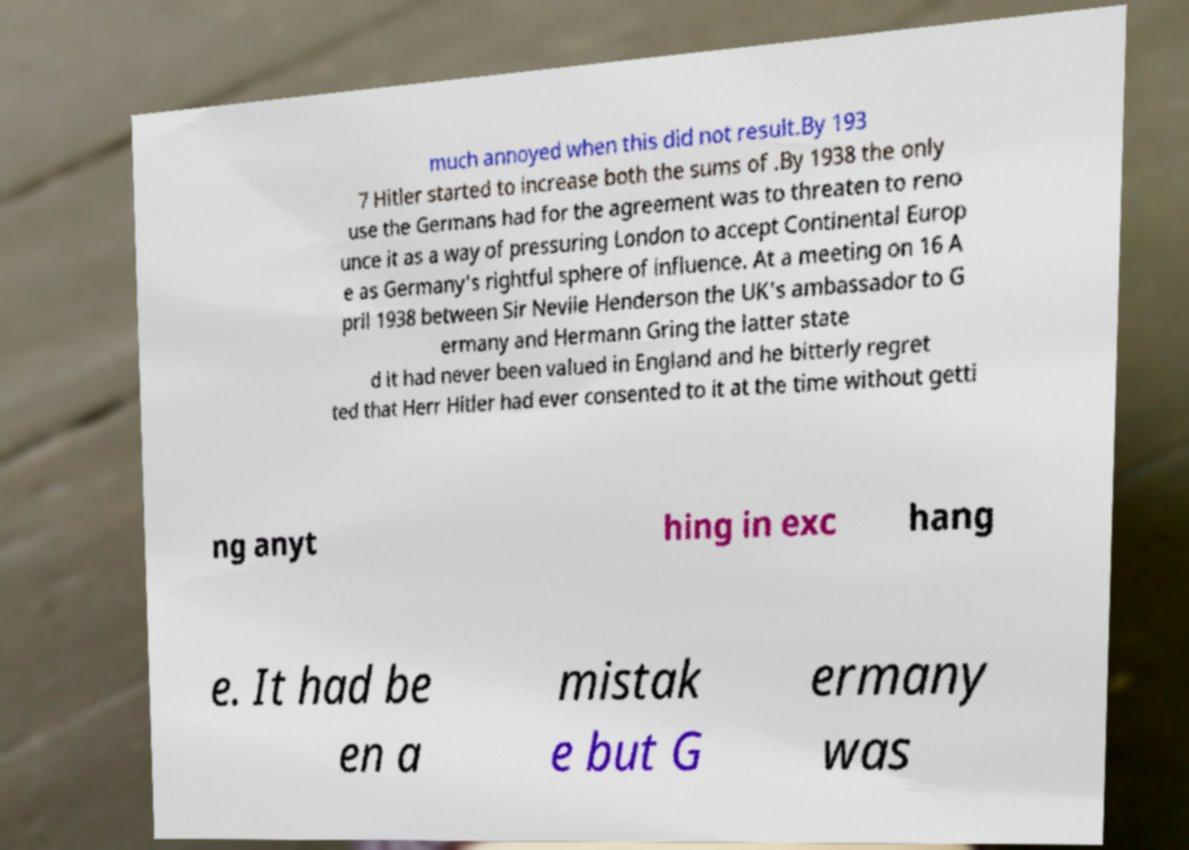Can you accurately transcribe the text from the provided image for me? much annoyed when this did not result.By 193 7 Hitler started to increase both the sums of .By 1938 the only use the Germans had for the agreement was to threaten to reno unce it as a way of pressuring London to accept Continental Europ e as Germany's rightful sphere of influence. At a meeting on 16 A pril 1938 between Sir Nevile Henderson the UK's ambassador to G ermany and Hermann Gring the latter state d it had never been valued in England and he bitterly regret ted that Herr Hitler had ever consented to it at the time without getti ng anyt hing in exc hang e. It had be en a mistak e but G ermany was 